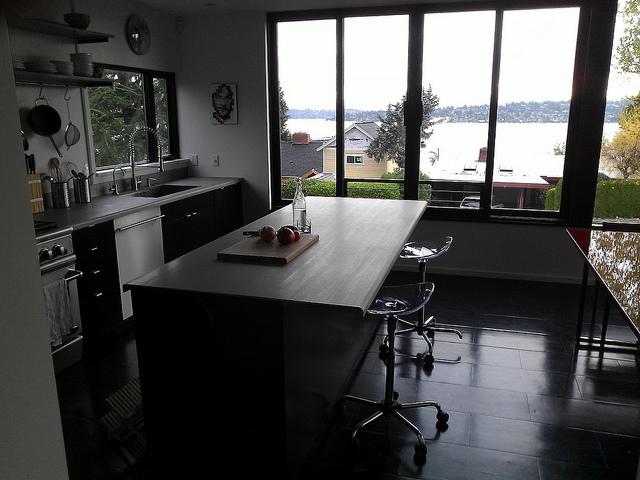What room of the house is this?
Quick response, please. Kitchen. Is there anyone in the room?
Quick response, please. No. Is this an industrial kitchen?
Short answer required. No. Is the door closed?
Concise answer only. No. Is there a tree in the image?
Be succinct. Yes. IS the floor shiny?
Short answer required. Yes. Is the kitchen sunny?
Give a very brief answer. No. Where was the photo taken?
Answer briefly. Kitchen. Is the room dark?
Concise answer only. Yes. What number of sinks are in the kitchen?
Quick response, please. 1. 